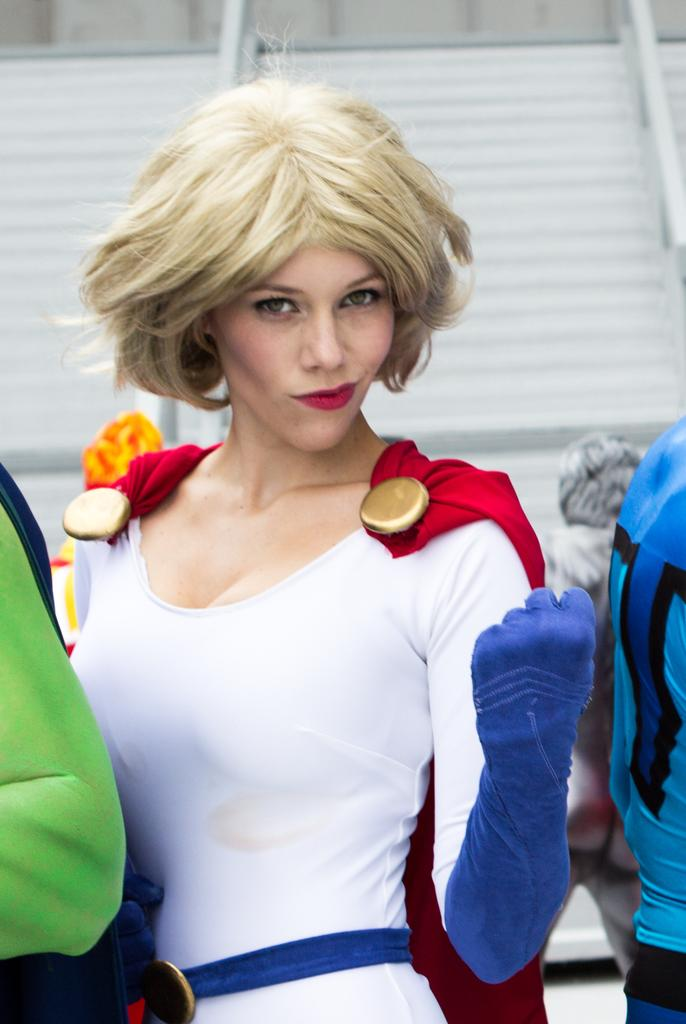Who is present in the image? There is a woman in the image. What is the woman doing in the image? The woman is standing. What can be seen in the background of the image? There is a wall in the background of the image. How many boys are present in the image? There are no boys present in the image; it features a woman. What type of care is the woman providing in the image? The image does not show the woman providing any care, as her actions are not specified. 